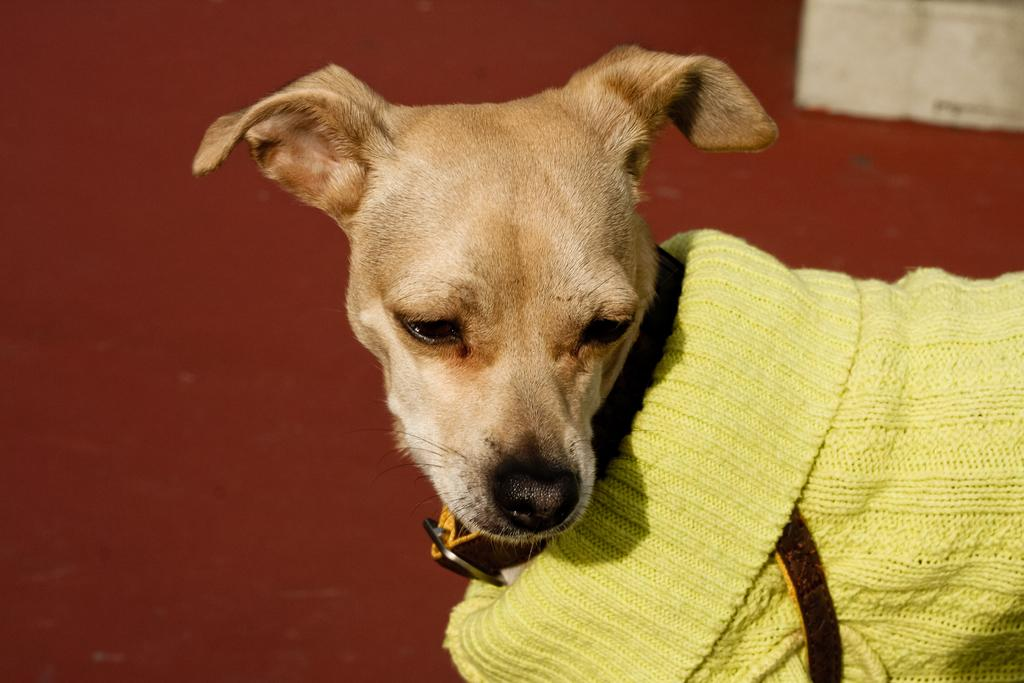What type of animal is in the image? There is a brown dog in the image. What is the dog wearing? The dog is wearing a yellow sweater. What color is the background of the image? The background of the image is brown. Can you describe the object in the top right corner of the image? There is an object in white color in the top right corner of the image. What type of jelly can be seen dripping from the dog's sweater in the image? There is no jelly present in the image, nor is it dripping from the dog's sweater. 